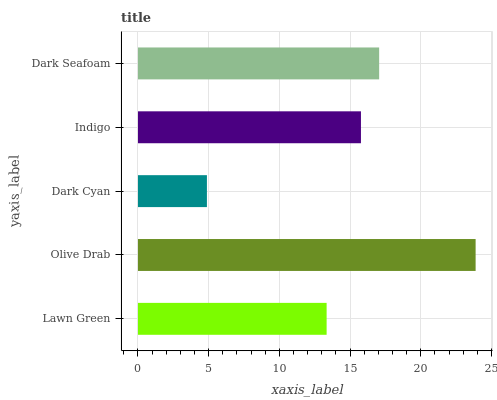Is Dark Cyan the minimum?
Answer yes or no. Yes. Is Olive Drab the maximum?
Answer yes or no. Yes. Is Olive Drab the minimum?
Answer yes or no. No. Is Dark Cyan the maximum?
Answer yes or no. No. Is Olive Drab greater than Dark Cyan?
Answer yes or no. Yes. Is Dark Cyan less than Olive Drab?
Answer yes or no. Yes. Is Dark Cyan greater than Olive Drab?
Answer yes or no. No. Is Olive Drab less than Dark Cyan?
Answer yes or no. No. Is Indigo the high median?
Answer yes or no. Yes. Is Indigo the low median?
Answer yes or no. Yes. Is Lawn Green the high median?
Answer yes or no. No. Is Lawn Green the low median?
Answer yes or no. No. 